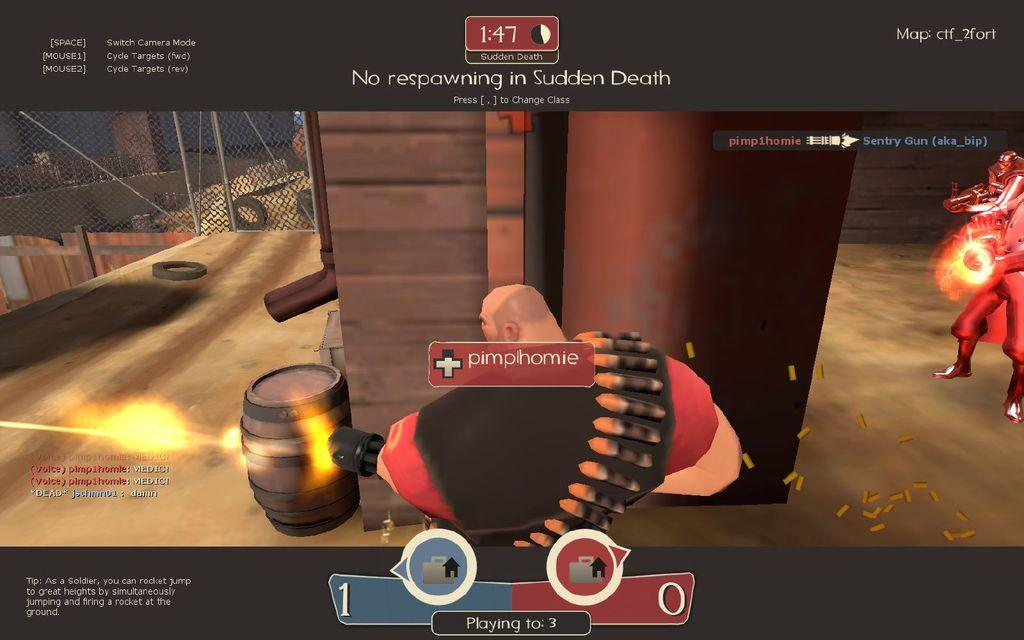What type of image is being described? The image is an animation. What structures can be seen in the image? There are fences in the image. What objects are present in the image? There are barrels in the image. What are the persons in the image doing? The persons in the image are firing. What type of card is being used by the persons in the image? There is no card present in the image; the persons are firing, not using any cards. 